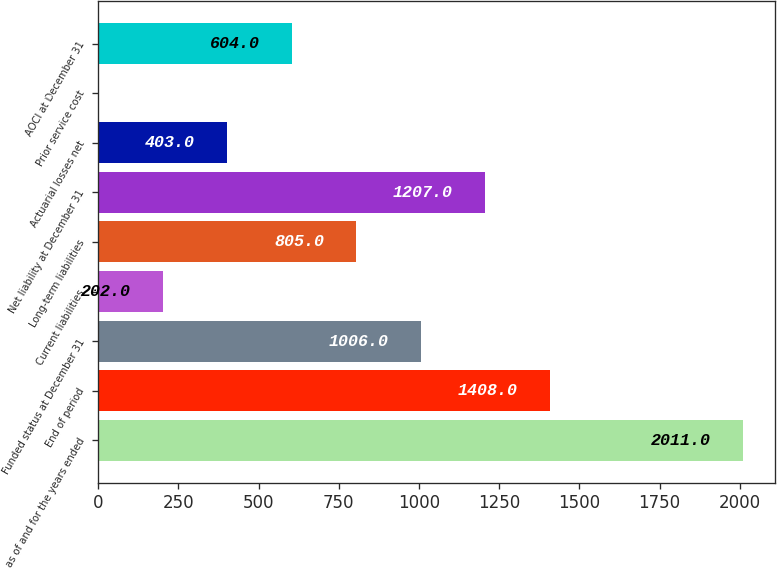<chart> <loc_0><loc_0><loc_500><loc_500><bar_chart><fcel>as of and for the years ended<fcel>End of period<fcel>Funded status at December 31<fcel>Current liabilities<fcel>Long-term liabilities<fcel>Net liability at December 31<fcel>Actuarial losses net<fcel>Prior service cost<fcel>AOCI at December 31<nl><fcel>2011<fcel>1408<fcel>1006<fcel>202<fcel>805<fcel>1207<fcel>403<fcel>1<fcel>604<nl></chart> 